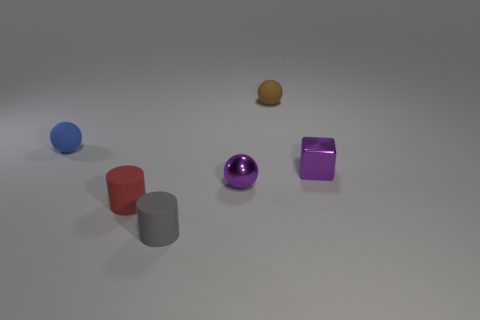Add 1 small brown matte cylinders. How many objects exist? 7 Subtract all rubber balls. How many balls are left? 1 Subtract all blocks. How many objects are left? 5 Subtract 1 purple cubes. How many objects are left? 5 Subtract all small gray objects. Subtract all brown spheres. How many objects are left? 4 Add 3 small blue spheres. How many small blue spheres are left? 4 Add 6 tiny red things. How many tiny red things exist? 7 